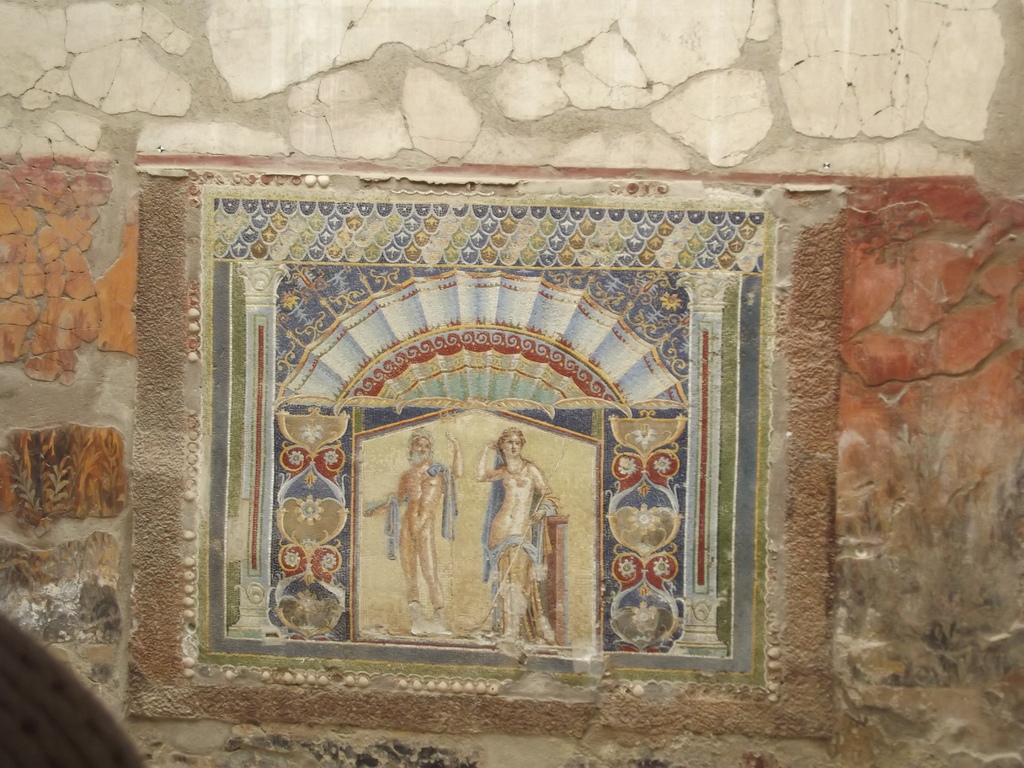What is on the wall in the image? There is a painted board on the wall in the image. What type of sound can be heard coming from the painted board in the image? There is no sound coming from the painted board in the image, as it is a static object. 